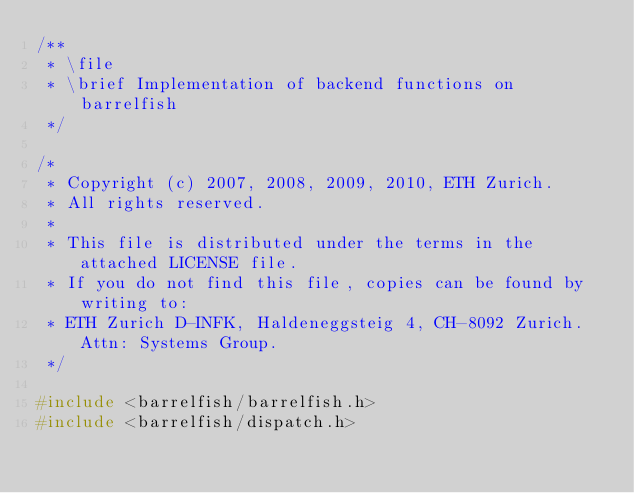Convert code to text. <code><loc_0><loc_0><loc_500><loc_500><_C_>/**
 * \file
 * \brief Implementation of backend functions on barrelfish
 */

/*
 * Copyright (c) 2007, 2008, 2009, 2010, ETH Zurich.
 * All rights reserved.
 *
 * This file is distributed under the terms in the attached LICENSE file.
 * If you do not find this file, copies can be found by writing to:
 * ETH Zurich D-INFK, Haldeneggsteig 4, CH-8092 Zurich. Attn: Systems Group.
 */

#include <barrelfish/barrelfish.h>
#include <barrelfish/dispatch.h></code> 